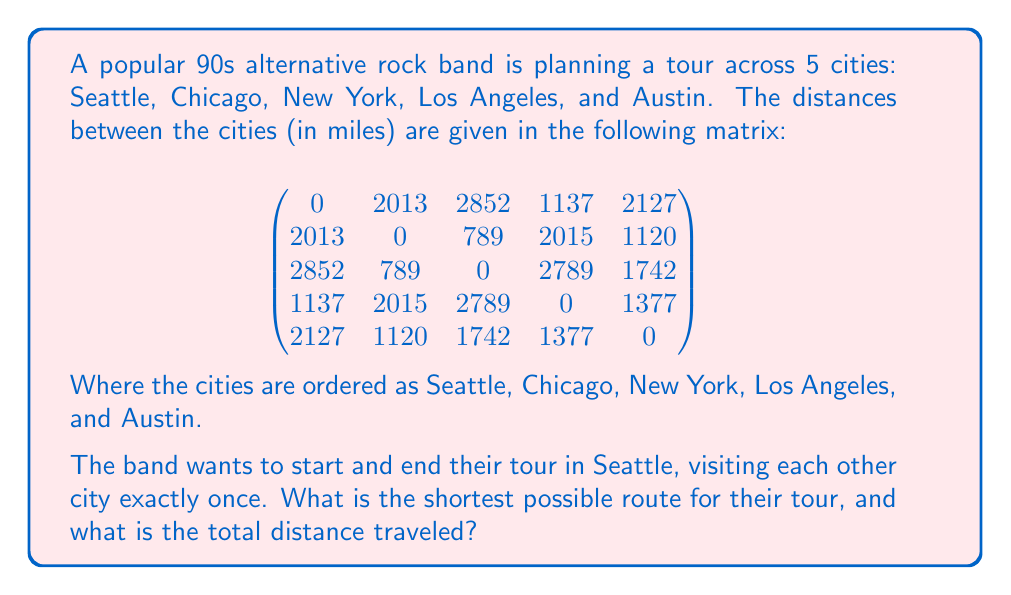What is the answer to this math problem? This problem is an instance of the Traveling Salesman Problem (TSP), which is NP-hard. For a small number of cities like this, we can solve it using a brute-force approach.

1) First, let's list all possible tours starting and ending in Seattle:
   - Seattle -> Chicago -> New York -> Los Angeles -> Austin -> Seattle
   - Seattle -> Chicago -> New York -> Austin -> Los Angeles -> Seattle
   - Seattle -> Chicago -> Los Angeles -> New York -> Austin -> Seattle
   - Seattle -> Chicago -> Los Angeles -> Austin -> New York -> Seattle
   - Seattle -> Chicago -> Austin -> New York -> Los Angeles -> Seattle
   - Seattle -> Chicago -> Austin -> Los Angeles -> New York -> Seattle
   (and 18 more permutations)

2) We need to calculate the total distance for each tour. Let's do this for the first tour:
   
   Seattle to Chicago: 2013
   Chicago to New York: 789
   New York to Los Angeles: 2789
   Los Angeles to Austin: 1377
   Austin to Seattle: 2127
   
   Total: 2013 + 789 + 2789 + 1377 + 2127 = 9095 miles

3) We would repeat this process for all 24 possible tours (4! = 24, as Seattle is fixed as start and end).

4) After calculating all tours, we find the minimum distance tour.

The shortest tour is:
Seattle -> Los Angeles -> Austin -> Chicago -> New York -> Seattle

With a total distance of:
1137 (Seattle to LA) + 1377 (LA to Austin) + 1120 (Austin to Chicago) + 789 (Chicago to NY) + 2852 (NY to Seattle) = 7275 miles
Answer: The shortest tour route is Seattle -> Los Angeles -> Austin -> Chicago -> New York -> Seattle, with a total distance of 7275 miles. 